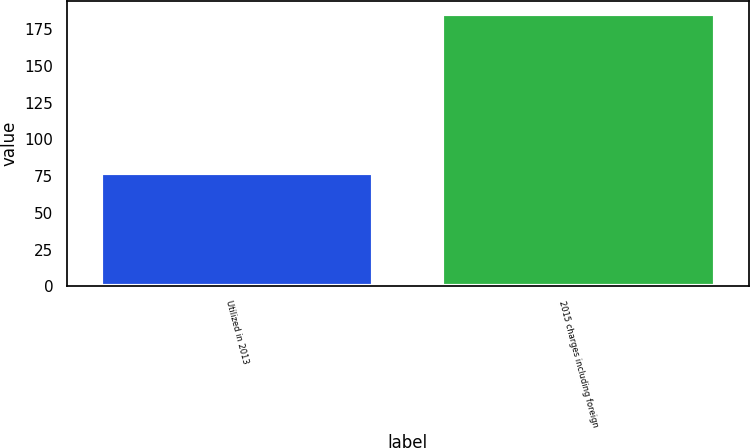<chart> <loc_0><loc_0><loc_500><loc_500><bar_chart><fcel>Utilized in 2013<fcel>2015 charges including foreign<nl><fcel>77<fcel>185.1<nl></chart> 